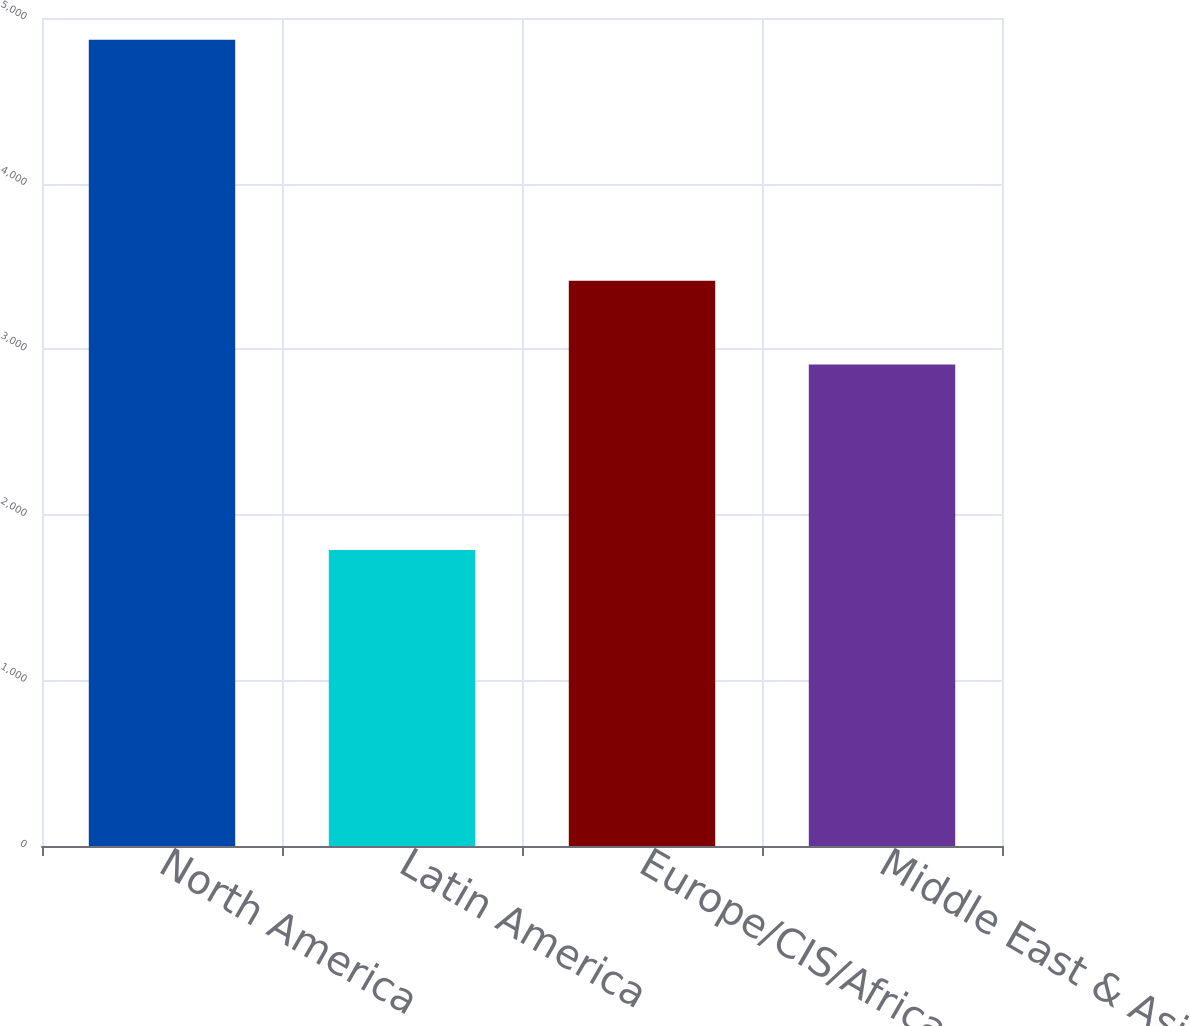<chart> <loc_0><loc_0><loc_500><loc_500><bar_chart><fcel>North America<fcel>Latin America<fcel>Europe/CIS/Africa<fcel>Middle East & Asia<nl><fcel>4868<fcel>1788<fcel>3414<fcel>2908<nl></chart> 